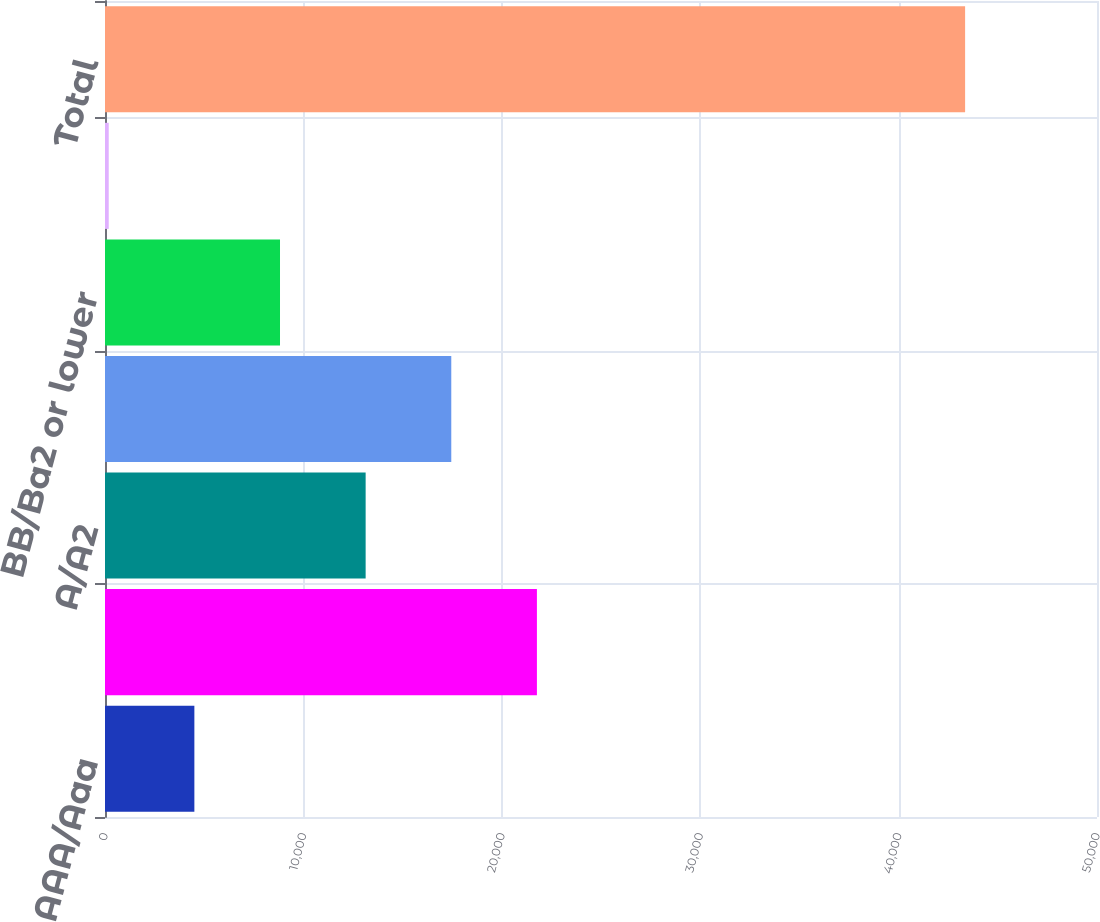Convert chart. <chart><loc_0><loc_0><loc_500><loc_500><bar_chart><fcel>AAA/Aaa<fcel>AA/Aa2<fcel>A/A2<fcel>BBB/Baa2<fcel>BB/Ba2 or lower<fcel>Unrated<fcel>Total<nl><fcel>4504.4<fcel>21770<fcel>13137.2<fcel>17453.6<fcel>8820.8<fcel>188<fcel>43352<nl></chart> 